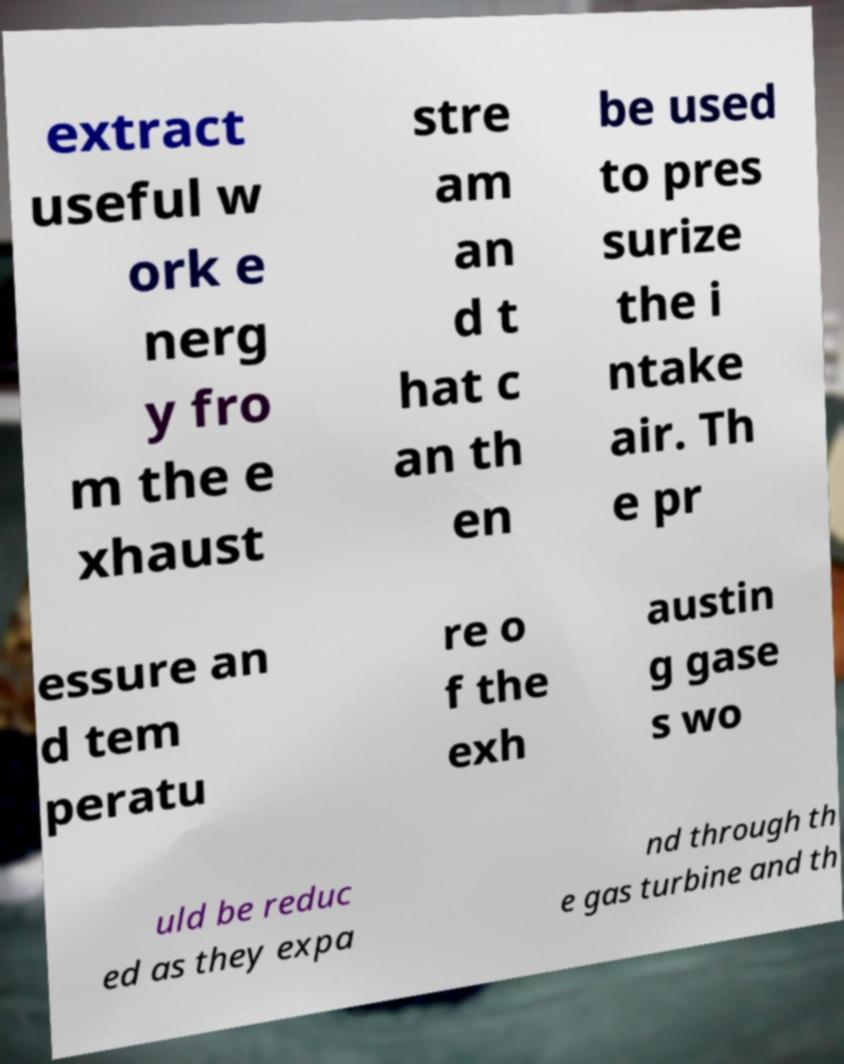What messages or text are displayed in this image? I need them in a readable, typed format. extract useful w ork e nerg y fro m the e xhaust stre am an d t hat c an th en be used to pres surize the i ntake air. Th e pr essure an d tem peratu re o f the exh austin g gase s wo uld be reduc ed as they expa nd through th e gas turbine and th 